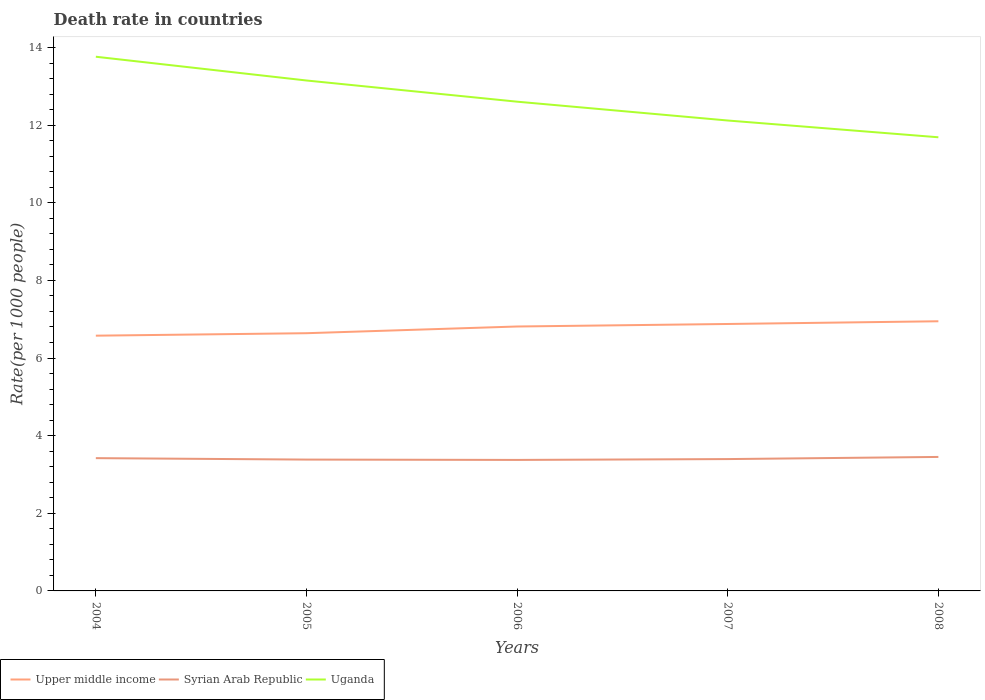Is the number of lines equal to the number of legend labels?
Offer a terse response. Yes. Across all years, what is the maximum death rate in Upper middle income?
Make the answer very short. 6.58. What is the total death rate in Upper middle income in the graph?
Your answer should be very brief. -0.37. What is the difference between the highest and the second highest death rate in Syrian Arab Republic?
Give a very brief answer. 0.08. What is the difference between the highest and the lowest death rate in Upper middle income?
Make the answer very short. 3. Are the values on the major ticks of Y-axis written in scientific E-notation?
Give a very brief answer. No. Does the graph contain any zero values?
Ensure brevity in your answer.  No. Does the graph contain grids?
Keep it short and to the point. No. How many legend labels are there?
Your answer should be very brief. 3. What is the title of the graph?
Make the answer very short. Death rate in countries. What is the label or title of the Y-axis?
Your response must be concise. Rate(per 1000 people). What is the Rate(per 1000 people) in Upper middle income in 2004?
Provide a succinct answer. 6.58. What is the Rate(per 1000 people) in Syrian Arab Republic in 2004?
Provide a short and direct response. 3.42. What is the Rate(per 1000 people) of Uganda in 2004?
Ensure brevity in your answer.  13.76. What is the Rate(per 1000 people) in Upper middle income in 2005?
Provide a short and direct response. 6.64. What is the Rate(per 1000 people) of Syrian Arab Republic in 2005?
Your answer should be very brief. 3.38. What is the Rate(per 1000 people) of Uganda in 2005?
Keep it short and to the point. 13.15. What is the Rate(per 1000 people) of Upper middle income in 2006?
Your response must be concise. 6.81. What is the Rate(per 1000 people) in Syrian Arab Republic in 2006?
Offer a very short reply. 3.38. What is the Rate(per 1000 people) in Uganda in 2006?
Provide a short and direct response. 12.61. What is the Rate(per 1000 people) of Upper middle income in 2007?
Keep it short and to the point. 6.88. What is the Rate(per 1000 people) in Syrian Arab Republic in 2007?
Ensure brevity in your answer.  3.4. What is the Rate(per 1000 people) in Uganda in 2007?
Keep it short and to the point. 12.12. What is the Rate(per 1000 people) in Upper middle income in 2008?
Your answer should be very brief. 6.95. What is the Rate(per 1000 people) of Syrian Arab Republic in 2008?
Make the answer very short. 3.45. What is the Rate(per 1000 people) of Uganda in 2008?
Provide a succinct answer. 11.69. Across all years, what is the maximum Rate(per 1000 people) of Upper middle income?
Keep it short and to the point. 6.95. Across all years, what is the maximum Rate(per 1000 people) of Syrian Arab Republic?
Your answer should be very brief. 3.45. Across all years, what is the maximum Rate(per 1000 people) in Uganda?
Make the answer very short. 13.76. Across all years, what is the minimum Rate(per 1000 people) of Upper middle income?
Ensure brevity in your answer.  6.58. Across all years, what is the minimum Rate(per 1000 people) in Syrian Arab Republic?
Make the answer very short. 3.38. Across all years, what is the minimum Rate(per 1000 people) in Uganda?
Offer a very short reply. 11.69. What is the total Rate(per 1000 people) in Upper middle income in the graph?
Make the answer very short. 33.85. What is the total Rate(per 1000 people) of Syrian Arab Republic in the graph?
Provide a succinct answer. 17.03. What is the total Rate(per 1000 people) in Uganda in the graph?
Provide a short and direct response. 63.33. What is the difference between the Rate(per 1000 people) of Upper middle income in 2004 and that in 2005?
Ensure brevity in your answer.  -0.06. What is the difference between the Rate(per 1000 people) in Syrian Arab Republic in 2004 and that in 2005?
Ensure brevity in your answer.  0.04. What is the difference between the Rate(per 1000 people) of Uganda in 2004 and that in 2005?
Offer a terse response. 0.61. What is the difference between the Rate(per 1000 people) of Upper middle income in 2004 and that in 2006?
Give a very brief answer. -0.24. What is the difference between the Rate(per 1000 people) in Syrian Arab Republic in 2004 and that in 2006?
Keep it short and to the point. 0.05. What is the difference between the Rate(per 1000 people) in Uganda in 2004 and that in 2006?
Offer a very short reply. 1.16. What is the difference between the Rate(per 1000 people) in Upper middle income in 2004 and that in 2007?
Your answer should be compact. -0.3. What is the difference between the Rate(per 1000 people) in Syrian Arab Republic in 2004 and that in 2007?
Keep it short and to the point. 0.02. What is the difference between the Rate(per 1000 people) in Uganda in 2004 and that in 2007?
Ensure brevity in your answer.  1.64. What is the difference between the Rate(per 1000 people) in Upper middle income in 2004 and that in 2008?
Make the answer very short. -0.37. What is the difference between the Rate(per 1000 people) in Syrian Arab Republic in 2004 and that in 2008?
Offer a very short reply. -0.03. What is the difference between the Rate(per 1000 people) in Uganda in 2004 and that in 2008?
Your response must be concise. 2.08. What is the difference between the Rate(per 1000 people) of Upper middle income in 2005 and that in 2006?
Give a very brief answer. -0.17. What is the difference between the Rate(per 1000 people) in Syrian Arab Republic in 2005 and that in 2006?
Offer a terse response. 0.01. What is the difference between the Rate(per 1000 people) of Uganda in 2005 and that in 2006?
Offer a very short reply. 0.55. What is the difference between the Rate(per 1000 people) of Upper middle income in 2005 and that in 2007?
Provide a succinct answer. -0.24. What is the difference between the Rate(per 1000 people) in Syrian Arab Republic in 2005 and that in 2007?
Your answer should be very brief. -0.01. What is the difference between the Rate(per 1000 people) in Uganda in 2005 and that in 2007?
Your answer should be compact. 1.03. What is the difference between the Rate(per 1000 people) of Upper middle income in 2005 and that in 2008?
Offer a very short reply. -0.31. What is the difference between the Rate(per 1000 people) in Syrian Arab Republic in 2005 and that in 2008?
Provide a succinct answer. -0.07. What is the difference between the Rate(per 1000 people) of Uganda in 2005 and that in 2008?
Give a very brief answer. 1.46. What is the difference between the Rate(per 1000 people) in Upper middle income in 2006 and that in 2007?
Offer a terse response. -0.07. What is the difference between the Rate(per 1000 people) in Syrian Arab Republic in 2006 and that in 2007?
Your answer should be compact. -0.02. What is the difference between the Rate(per 1000 people) in Uganda in 2006 and that in 2007?
Provide a succinct answer. 0.48. What is the difference between the Rate(per 1000 people) in Upper middle income in 2006 and that in 2008?
Make the answer very short. -0.13. What is the difference between the Rate(per 1000 people) in Syrian Arab Republic in 2006 and that in 2008?
Provide a short and direct response. -0.08. What is the difference between the Rate(per 1000 people) of Uganda in 2006 and that in 2008?
Keep it short and to the point. 0.92. What is the difference between the Rate(per 1000 people) of Upper middle income in 2007 and that in 2008?
Your answer should be compact. -0.07. What is the difference between the Rate(per 1000 people) in Syrian Arab Republic in 2007 and that in 2008?
Provide a succinct answer. -0.06. What is the difference between the Rate(per 1000 people) in Uganda in 2007 and that in 2008?
Provide a succinct answer. 0.43. What is the difference between the Rate(per 1000 people) in Upper middle income in 2004 and the Rate(per 1000 people) in Syrian Arab Republic in 2005?
Make the answer very short. 3.19. What is the difference between the Rate(per 1000 people) in Upper middle income in 2004 and the Rate(per 1000 people) in Uganda in 2005?
Provide a short and direct response. -6.57. What is the difference between the Rate(per 1000 people) of Syrian Arab Republic in 2004 and the Rate(per 1000 people) of Uganda in 2005?
Give a very brief answer. -9.73. What is the difference between the Rate(per 1000 people) of Upper middle income in 2004 and the Rate(per 1000 people) of Syrian Arab Republic in 2006?
Your response must be concise. 3.2. What is the difference between the Rate(per 1000 people) of Upper middle income in 2004 and the Rate(per 1000 people) of Uganda in 2006?
Your answer should be compact. -6.03. What is the difference between the Rate(per 1000 people) in Syrian Arab Republic in 2004 and the Rate(per 1000 people) in Uganda in 2006?
Provide a succinct answer. -9.18. What is the difference between the Rate(per 1000 people) in Upper middle income in 2004 and the Rate(per 1000 people) in Syrian Arab Republic in 2007?
Your answer should be compact. 3.18. What is the difference between the Rate(per 1000 people) of Upper middle income in 2004 and the Rate(per 1000 people) of Uganda in 2007?
Your response must be concise. -5.54. What is the difference between the Rate(per 1000 people) of Syrian Arab Republic in 2004 and the Rate(per 1000 people) of Uganda in 2007?
Ensure brevity in your answer.  -8.7. What is the difference between the Rate(per 1000 people) in Upper middle income in 2004 and the Rate(per 1000 people) in Syrian Arab Republic in 2008?
Provide a succinct answer. 3.12. What is the difference between the Rate(per 1000 people) in Upper middle income in 2004 and the Rate(per 1000 people) in Uganda in 2008?
Your answer should be very brief. -5.11. What is the difference between the Rate(per 1000 people) of Syrian Arab Republic in 2004 and the Rate(per 1000 people) of Uganda in 2008?
Your response must be concise. -8.27. What is the difference between the Rate(per 1000 people) in Upper middle income in 2005 and the Rate(per 1000 people) in Syrian Arab Republic in 2006?
Ensure brevity in your answer.  3.27. What is the difference between the Rate(per 1000 people) in Upper middle income in 2005 and the Rate(per 1000 people) in Uganda in 2006?
Your response must be concise. -5.96. What is the difference between the Rate(per 1000 people) in Syrian Arab Republic in 2005 and the Rate(per 1000 people) in Uganda in 2006?
Your response must be concise. -9.22. What is the difference between the Rate(per 1000 people) of Upper middle income in 2005 and the Rate(per 1000 people) of Syrian Arab Republic in 2007?
Your response must be concise. 3.24. What is the difference between the Rate(per 1000 people) in Upper middle income in 2005 and the Rate(per 1000 people) in Uganda in 2007?
Your response must be concise. -5.48. What is the difference between the Rate(per 1000 people) of Syrian Arab Republic in 2005 and the Rate(per 1000 people) of Uganda in 2007?
Provide a succinct answer. -8.74. What is the difference between the Rate(per 1000 people) in Upper middle income in 2005 and the Rate(per 1000 people) in Syrian Arab Republic in 2008?
Give a very brief answer. 3.19. What is the difference between the Rate(per 1000 people) of Upper middle income in 2005 and the Rate(per 1000 people) of Uganda in 2008?
Your response must be concise. -5.05. What is the difference between the Rate(per 1000 people) in Syrian Arab Republic in 2005 and the Rate(per 1000 people) in Uganda in 2008?
Your answer should be compact. -8.3. What is the difference between the Rate(per 1000 people) of Upper middle income in 2006 and the Rate(per 1000 people) of Syrian Arab Republic in 2007?
Give a very brief answer. 3.42. What is the difference between the Rate(per 1000 people) in Upper middle income in 2006 and the Rate(per 1000 people) in Uganda in 2007?
Keep it short and to the point. -5.31. What is the difference between the Rate(per 1000 people) of Syrian Arab Republic in 2006 and the Rate(per 1000 people) of Uganda in 2007?
Your response must be concise. -8.74. What is the difference between the Rate(per 1000 people) in Upper middle income in 2006 and the Rate(per 1000 people) in Syrian Arab Republic in 2008?
Make the answer very short. 3.36. What is the difference between the Rate(per 1000 people) in Upper middle income in 2006 and the Rate(per 1000 people) in Uganda in 2008?
Keep it short and to the point. -4.88. What is the difference between the Rate(per 1000 people) of Syrian Arab Republic in 2006 and the Rate(per 1000 people) of Uganda in 2008?
Provide a succinct answer. -8.31. What is the difference between the Rate(per 1000 people) in Upper middle income in 2007 and the Rate(per 1000 people) in Syrian Arab Republic in 2008?
Give a very brief answer. 3.43. What is the difference between the Rate(per 1000 people) in Upper middle income in 2007 and the Rate(per 1000 people) in Uganda in 2008?
Your answer should be compact. -4.81. What is the difference between the Rate(per 1000 people) in Syrian Arab Republic in 2007 and the Rate(per 1000 people) in Uganda in 2008?
Give a very brief answer. -8.29. What is the average Rate(per 1000 people) of Upper middle income per year?
Offer a terse response. 6.77. What is the average Rate(per 1000 people) in Syrian Arab Republic per year?
Make the answer very short. 3.41. What is the average Rate(per 1000 people) of Uganda per year?
Offer a terse response. 12.67. In the year 2004, what is the difference between the Rate(per 1000 people) in Upper middle income and Rate(per 1000 people) in Syrian Arab Republic?
Keep it short and to the point. 3.16. In the year 2004, what is the difference between the Rate(per 1000 people) of Upper middle income and Rate(per 1000 people) of Uganda?
Your response must be concise. -7.19. In the year 2004, what is the difference between the Rate(per 1000 people) in Syrian Arab Republic and Rate(per 1000 people) in Uganda?
Ensure brevity in your answer.  -10.34. In the year 2005, what is the difference between the Rate(per 1000 people) of Upper middle income and Rate(per 1000 people) of Syrian Arab Republic?
Provide a succinct answer. 3.26. In the year 2005, what is the difference between the Rate(per 1000 people) in Upper middle income and Rate(per 1000 people) in Uganda?
Offer a terse response. -6.51. In the year 2005, what is the difference between the Rate(per 1000 people) in Syrian Arab Republic and Rate(per 1000 people) in Uganda?
Keep it short and to the point. -9.77. In the year 2006, what is the difference between the Rate(per 1000 people) in Upper middle income and Rate(per 1000 people) in Syrian Arab Republic?
Keep it short and to the point. 3.44. In the year 2006, what is the difference between the Rate(per 1000 people) in Upper middle income and Rate(per 1000 people) in Uganda?
Offer a terse response. -5.79. In the year 2006, what is the difference between the Rate(per 1000 people) of Syrian Arab Republic and Rate(per 1000 people) of Uganda?
Give a very brief answer. -9.23. In the year 2007, what is the difference between the Rate(per 1000 people) in Upper middle income and Rate(per 1000 people) in Syrian Arab Republic?
Your answer should be very brief. 3.48. In the year 2007, what is the difference between the Rate(per 1000 people) in Upper middle income and Rate(per 1000 people) in Uganda?
Keep it short and to the point. -5.24. In the year 2007, what is the difference between the Rate(per 1000 people) of Syrian Arab Republic and Rate(per 1000 people) of Uganda?
Ensure brevity in your answer.  -8.72. In the year 2008, what is the difference between the Rate(per 1000 people) in Upper middle income and Rate(per 1000 people) in Syrian Arab Republic?
Your response must be concise. 3.5. In the year 2008, what is the difference between the Rate(per 1000 people) in Upper middle income and Rate(per 1000 people) in Uganda?
Give a very brief answer. -4.74. In the year 2008, what is the difference between the Rate(per 1000 people) in Syrian Arab Republic and Rate(per 1000 people) in Uganda?
Keep it short and to the point. -8.24. What is the ratio of the Rate(per 1000 people) in Syrian Arab Republic in 2004 to that in 2005?
Make the answer very short. 1.01. What is the ratio of the Rate(per 1000 people) in Uganda in 2004 to that in 2005?
Offer a very short reply. 1.05. What is the ratio of the Rate(per 1000 people) in Upper middle income in 2004 to that in 2006?
Make the answer very short. 0.97. What is the ratio of the Rate(per 1000 people) in Syrian Arab Republic in 2004 to that in 2006?
Make the answer very short. 1.01. What is the ratio of the Rate(per 1000 people) in Uganda in 2004 to that in 2006?
Make the answer very short. 1.09. What is the ratio of the Rate(per 1000 people) in Upper middle income in 2004 to that in 2007?
Provide a succinct answer. 0.96. What is the ratio of the Rate(per 1000 people) in Syrian Arab Republic in 2004 to that in 2007?
Your answer should be very brief. 1.01. What is the ratio of the Rate(per 1000 people) of Uganda in 2004 to that in 2007?
Ensure brevity in your answer.  1.14. What is the ratio of the Rate(per 1000 people) in Upper middle income in 2004 to that in 2008?
Provide a short and direct response. 0.95. What is the ratio of the Rate(per 1000 people) in Uganda in 2004 to that in 2008?
Your answer should be very brief. 1.18. What is the ratio of the Rate(per 1000 people) in Upper middle income in 2005 to that in 2006?
Offer a terse response. 0.97. What is the ratio of the Rate(per 1000 people) in Syrian Arab Republic in 2005 to that in 2006?
Your response must be concise. 1. What is the ratio of the Rate(per 1000 people) of Uganda in 2005 to that in 2006?
Ensure brevity in your answer.  1.04. What is the ratio of the Rate(per 1000 people) in Upper middle income in 2005 to that in 2007?
Give a very brief answer. 0.97. What is the ratio of the Rate(per 1000 people) of Uganda in 2005 to that in 2007?
Your response must be concise. 1.09. What is the ratio of the Rate(per 1000 people) of Upper middle income in 2005 to that in 2008?
Your answer should be compact. 0.96. What is the ratio of the Rate(per 1000 people) in Syrian Arab Republic in 2005 to that in 2008?
Give a very brief answer. 0.98. What is the ratio of the Rate(per 1000 people) in Uganda in 2005 to that in 2008?
Offer a very short reply. 1.13. What is the ratio of the Rate(per 1000 people) of Upper middle income in 2006 to that in 2007?
Offer a very short reply. 0.99. What is the ratio of the Rate(per 1000 people) of Syrian Arab Republic in 2006 to that in 2007?
Give a very brief answer. 0.99. What is the ratio of the Rate(per 1000 people) of Uganda in 2006 to that in 2007?
Make the answer very short. 1.04. What is the ratio of the Rate(per 1000 people) of Upper middle income in 2006 to that in 2008?
Give a very brief answer. 0.98. What is the ratio of the Rate(per 1000 people) in Syrian Arab Republic in 2006 to that in 2008?
Give a very brief answer. 0.98. What is the ratio of the Rate(per 1000 people) of Uganda in 2006 to that in 2008?
Your answer should be very brief. 1.08. What is the ratio of the Rate(per 1000 people) of Upper middle income in 2007 to that in 2008?
Provide a succinct answer. 0.99. What is the ratio of the Rate(per 1000 people) of Syrian Arab Republic in 2007 to that in 2008?
Your answer should be very brief. 0.98. What is the difference between the highest and the second highest Rate(per 1000 people) of Upper middle income?
Your answer should be very brief. 0.07. What is the difference between the highest and the second highest Rate(per 1000 people) of Syrian Arab Republic?
Offer a very short reply. 0.03. What is the difference between the highest and the second highest Rate(per 1000 people) in Uganda?
Your answer should be very brief. 0.61. What is the difference between the highest and the lowest Rate(per 1000 people) of Upper middle income?
Your answer should be compact. 0.37. What is the difference between the highest and the lowest Rate(per 1000 people) of Syrian Arab Republic?
Provide a succinct answer. 0.08. What is the difference between the highest and the lowest Rate(per 1000 people) of Uganda?
Offer a very short reply. 2.08. 